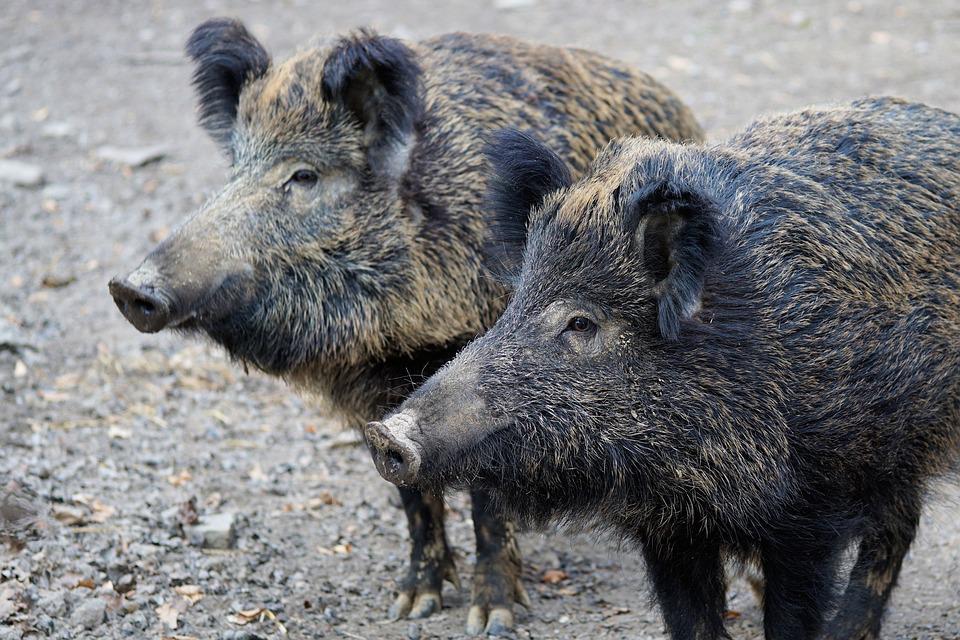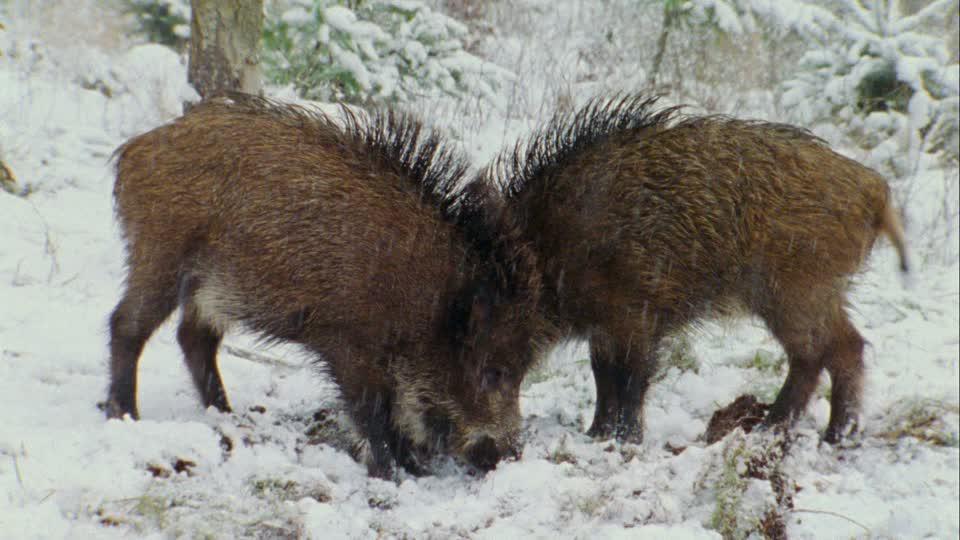The first image is the image on the left, the second image is the image on the right. Assess this claim about the two images: "The one boar in the left image is facing more toward the camera than the boar in the right image.". Correct or not? Answer yes or no. No. 